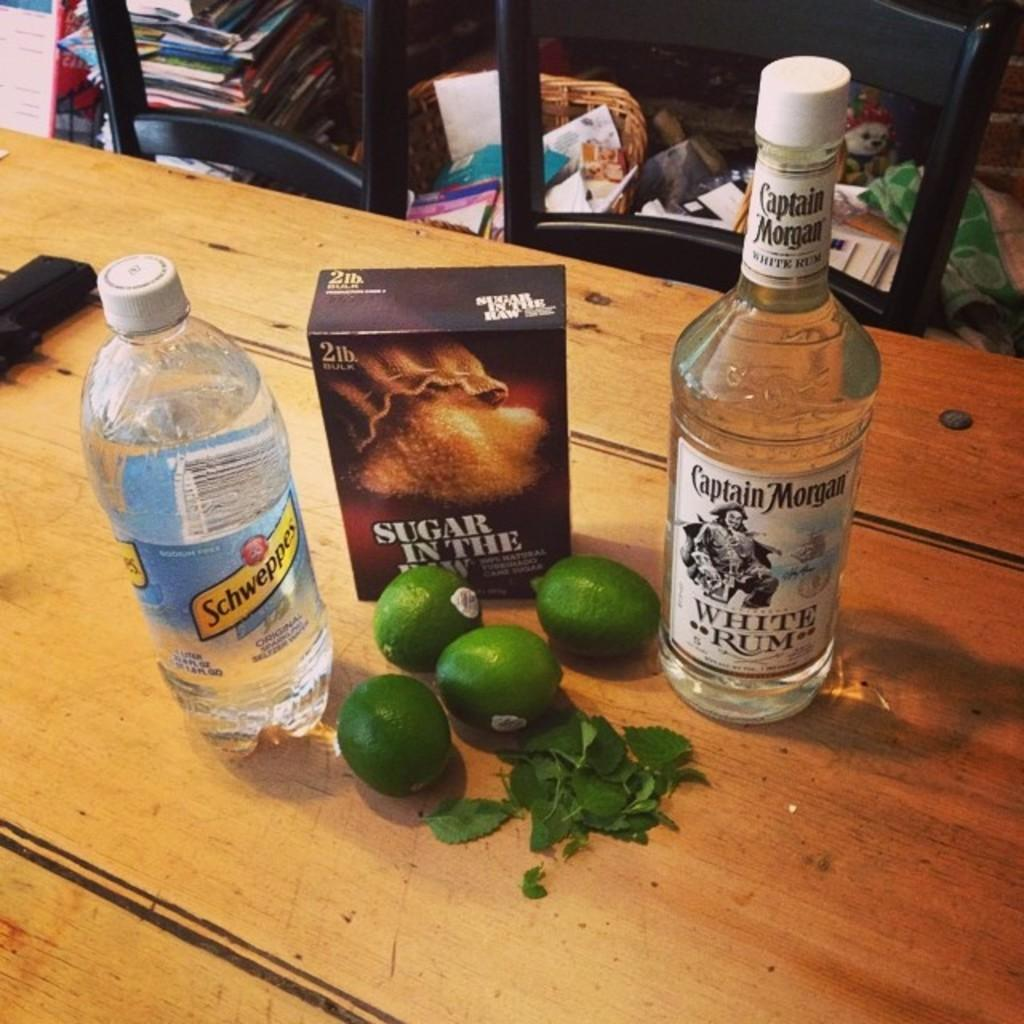What type of beverages are featured in the image? There are wine bottles and a soda bottle in the image. What other items can be seen in the image? There are lemons in the image. What is present in the background of the image? A book is present in the backdrop of the image. What type of meat is being prepared on the grill in the image? There is no grill or meat present in the image. How many sheep can be seen grazing in the background of the image? There are no sheep present in the image. 